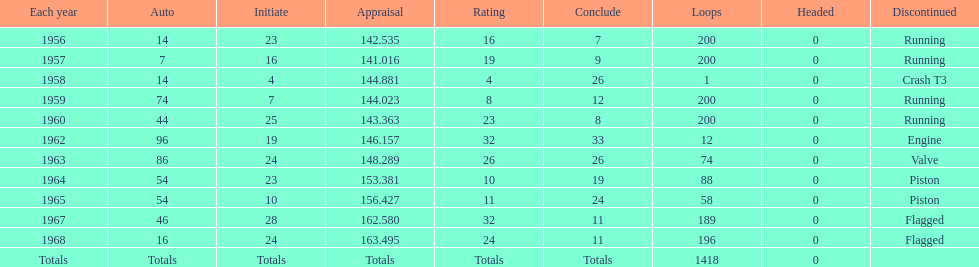What was its best starting position? 4. 